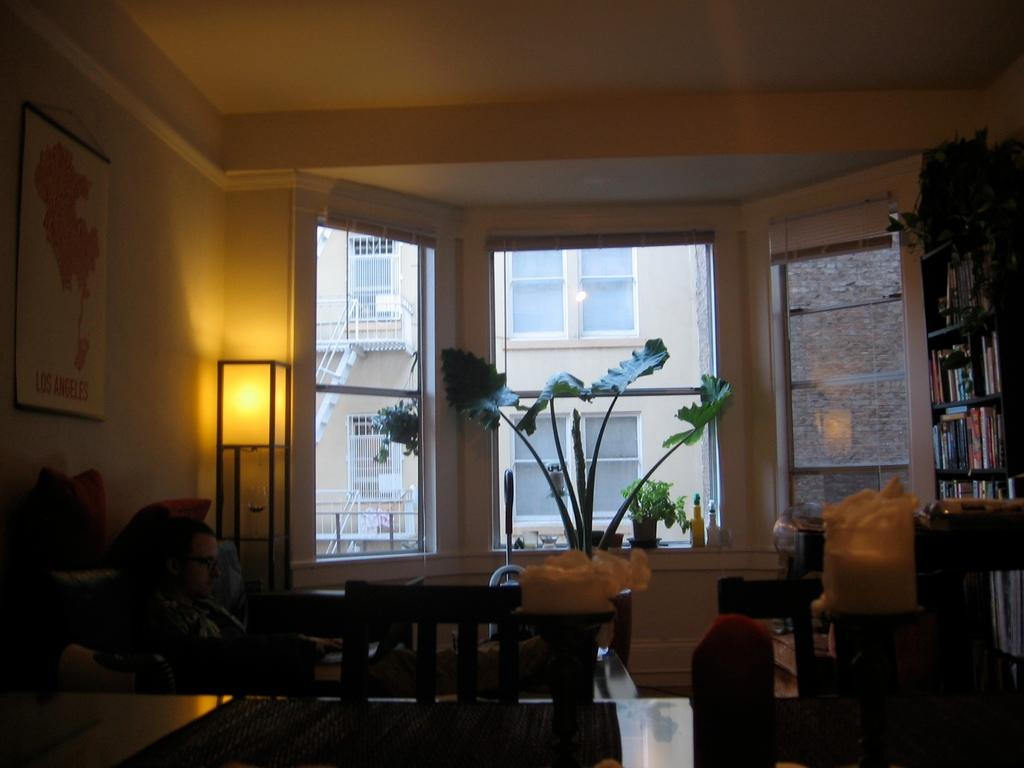What type of furniture is present in the image? There is a table and chairs in the image. What can be seen on the right side of the image? There are book shelves on the right side of the image. What is located near the window at the back of the image? There is a plant pot near the window at the back of the image. What type of lighting is present in the image? There is a lamp in the image. What type of decorative item is present in the image? There is a photo frame in the image. What type of quill is used to write on the book shelves in the image? There is no quill present in the image, and the book shelves are not used for writing. What degree is the person in the photo frame in the image? There is no person in the photo frame in the image, so it is not possible to determine their degree. 